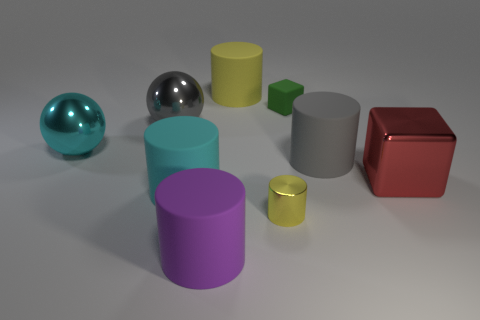Subtract all big cylinders. How many cylinders are left? 1 Subtract all cyan spheres. How many yellow cylinders are left? 2 Subtract all cyan cylinders. How many cylinders are left? 4 Subtract 5 cylinders. How many cylinders are left? 0 Subtract all cylinders. How many objects are left? 4 Add 1 purple matte things. How many objects exist? 10 Subtract all blue cylinders. Subtract all cyan blocks. How many cylinders are left? 5 Subtract all large metallic spheres. Subtract all cyan matte objects. How many objects are left? 6 Add 7 tiny green cubes. How many tiny green cubes are left? 8 Add 4 gray balls. How many gray balls exist? 5 